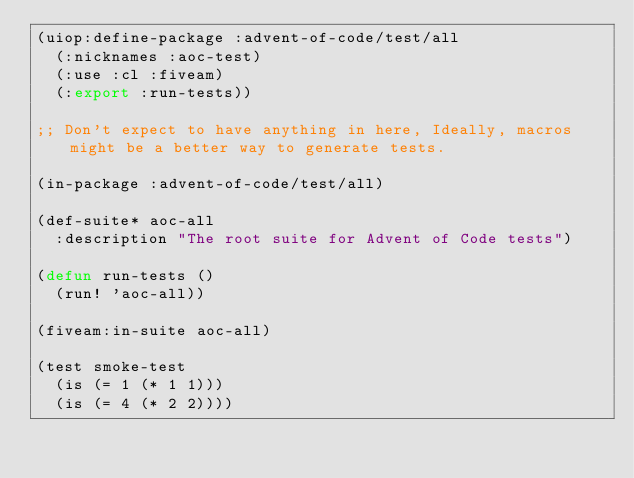Convert code to text. <code><loc_0><loc_0><loc_500><loc_500><_Lisp_>(uiop:define-package :advent-of-code/test/all
  (:nicknames :aoc-test)
  (:use :cl :fiveam)
  (:export :run-tests))

;; Don't expect to have anything in here, Ideally, macros might be a better way to generate tests.

(in-package :advent-of-code/test/all)

(def-suite* aoc-all
  :description "The root suite for Advent of Code tests")

(defun run-tests ()
  (run! 'aoc-all))

(fiveam:in-suite aoc-all)

(test smoke-test
  (is (= 1 (* 1 1)))
  (is (= 4 (* 2 2))))
</code> 